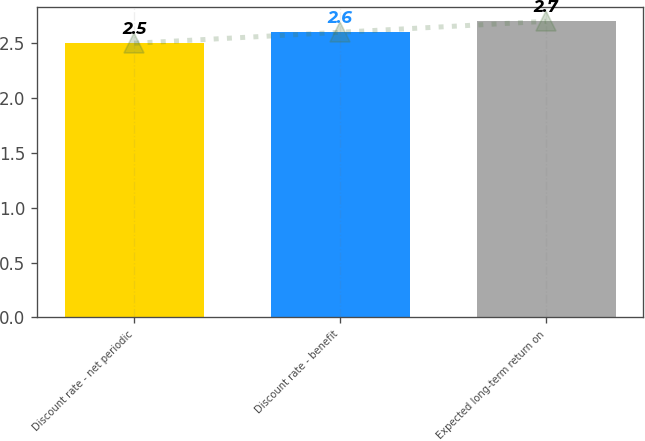Convert chart. <chart><loc_0><loc_0><loc_500><loc_500><bar_chart><fcel>Discount rate - net periodic<fcel>Discount rate - benefit<fcel>Expected long-term return on<nl><fcel>2.5<fcel>2.6<fcel>2.7<nl></chart> 